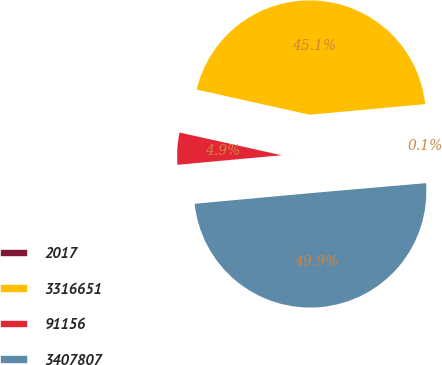<chart> <loc_0><loc_0><loc_500><loc_500><pie_chart><fcel>2017<fcel>3316651<fcel>91156<fcel>3407807<nl><fcel>0.08%<fcel>45.06%<fcel>4.94%<fcel>49.92%<nl></chart> 